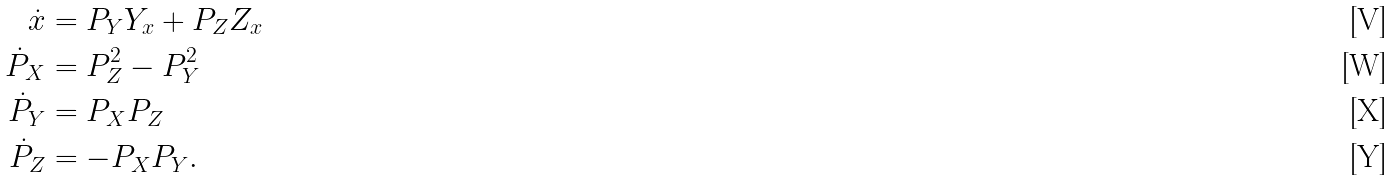Convert formula to latex. <formula><loc_0><loc_0><loc_500><loc_500>\dot { x } & = P _ { Y } Y _ { x } + P _ { Z } Z _ { x } \\ \dot { P } _ { X } & = P _ { Z } ^ { 2 } - P _ { Y } ^ { 2 } \\ \dot { P } _ { Y } & = P _ { X } P _ { Z } \\ \dot { P } _ { Z } & = - P _ { X } P _ { Y } .</formula> 